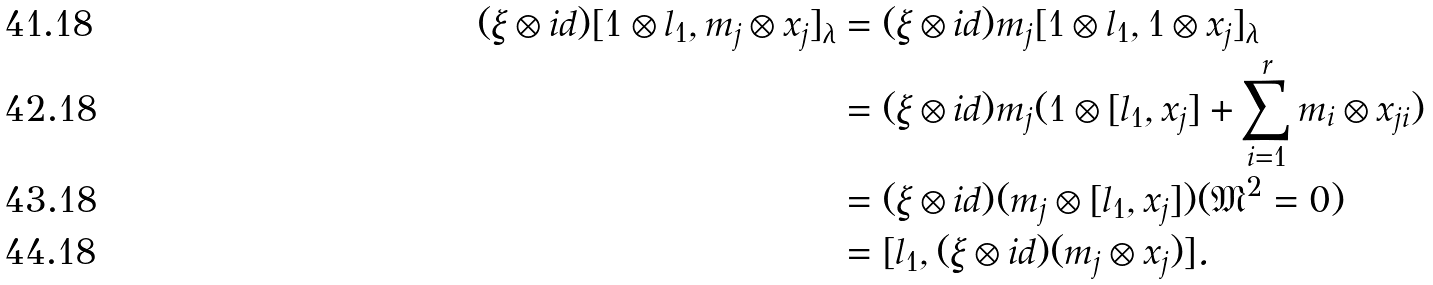Convert formula to latex. <formula><loc_0><loc_0><loc_500><loc_500>( \xi \otimes i d ) [ 1 \otimes l _ { 1 } , m _ { j } \otimes x _ { j } ] _ { \lambda } & = ( \xi \otimes i d ) m _ { j } [ 1 \otimes l _ { 1 } , 1 \otimes x _ { j } ] _ { \lambda } \\ & = ( \xi \otimes i d ) m _ { j } ( 1 \otimes [ l _ { 1 } , x _ { j } ] + \sum _ { i = 1 } ^ { r } m _ { i } \otimes x _ { j i } ) \\ & = ( \xi \otimes i d ) ( m _ { j } \otimes [ l _ { 1 } , x _ { j } ] ) ( \mathfrak { M } ^ { 2 } = 0 ) \\ & = [ l _ { 1 } , ( \xi \otimes i d ) ( m _ { j } \otimes x _ { j } ) ] .</formula> 